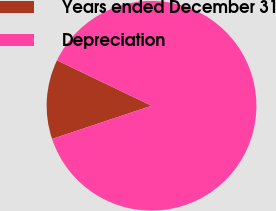Convert chart. <chart><loc_0><loc_0><loc_500><loc_500><pie_chart><fcel>Years ended December 31<fcel>Depreciation<nl><fcel>12.25%<fcel>87.75%<nl></chart> 